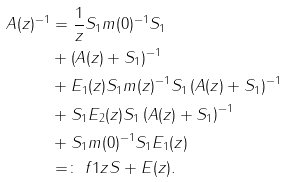Convert formula to latex. <formula><loc_0><loc_0><loc_500><loc_500>A ( z ) ^ { - 1 } & = \frac { 1 } { z } S _ { 1 } m ( 0 ) ^ { - 1 } S _ { 1 } \\ & + \left ( A ( z ) + S _ { 1 } \right ) ^ { - 1 } \\ & + E _ { 1 } ( z ) S _ { 1 } m ( z ) ^ { - 1 } S _ { 1 } \left ( A ( z ) + S _ { 1 } \right ) ^ { - 1 } \\ & + S _ { 1 } E _ { 2 } ( z ) S _ { 1 } \left ( A ( z ) + S _ { 1 } \right ) ^ { - 1 } \\ & + S _ { 1 } m ( 0 ) ^ { - 1 } S _ { 1 } E _ { 1 } ( z ) \\ & = \colon \ f { 1 } { z } S + E ( z ) .</formula> 